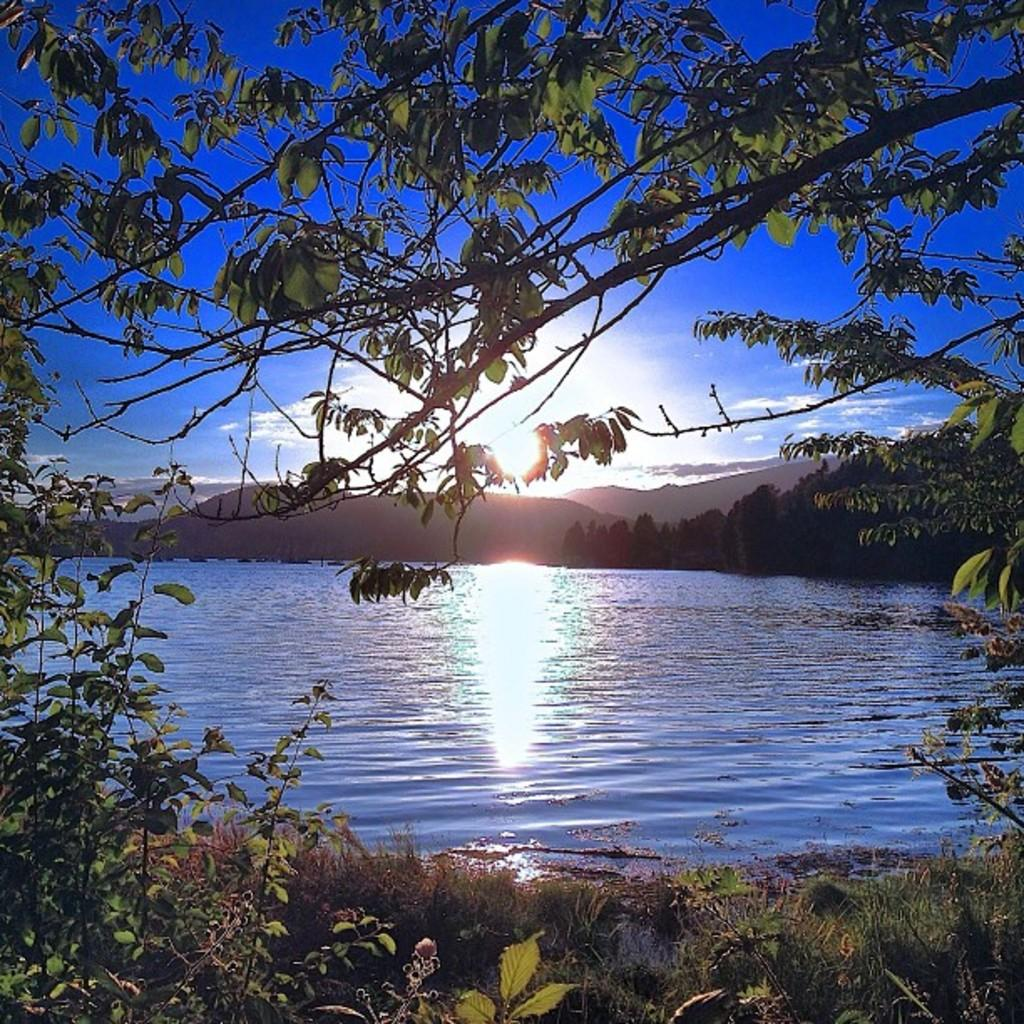What type of vegetation can be seen in the image? There are trees in the image. What natural feature is visible in the image? There is water visible in the image. What geographical feature can be seen in the distance? There are mountains in the image. What celestial body is visible in the sky? The sun is visible in the sky. Where is the doctor located in the image? There is no doctor present in the image. What type of crime is being committed in the image? There is no crime being committed in the image. 